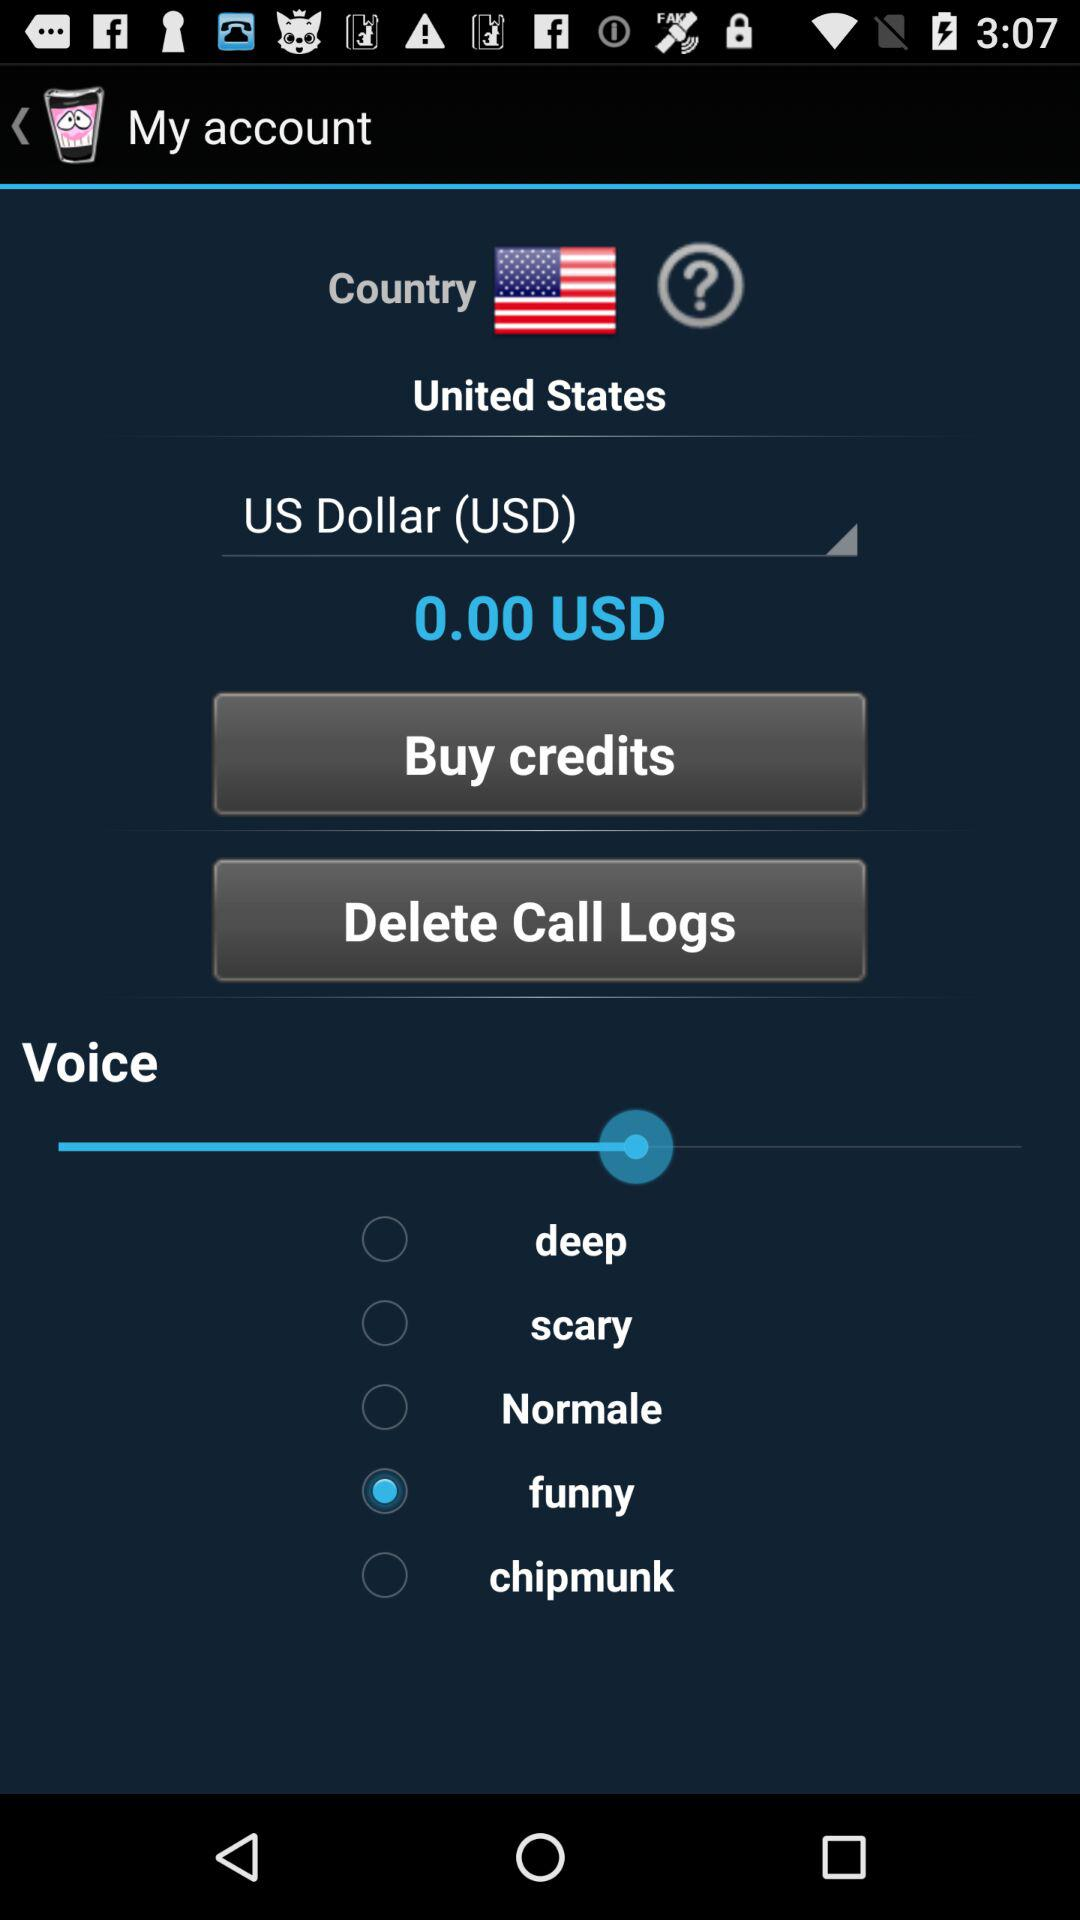What type of voice is selected? The selected type of voice is "funny". 